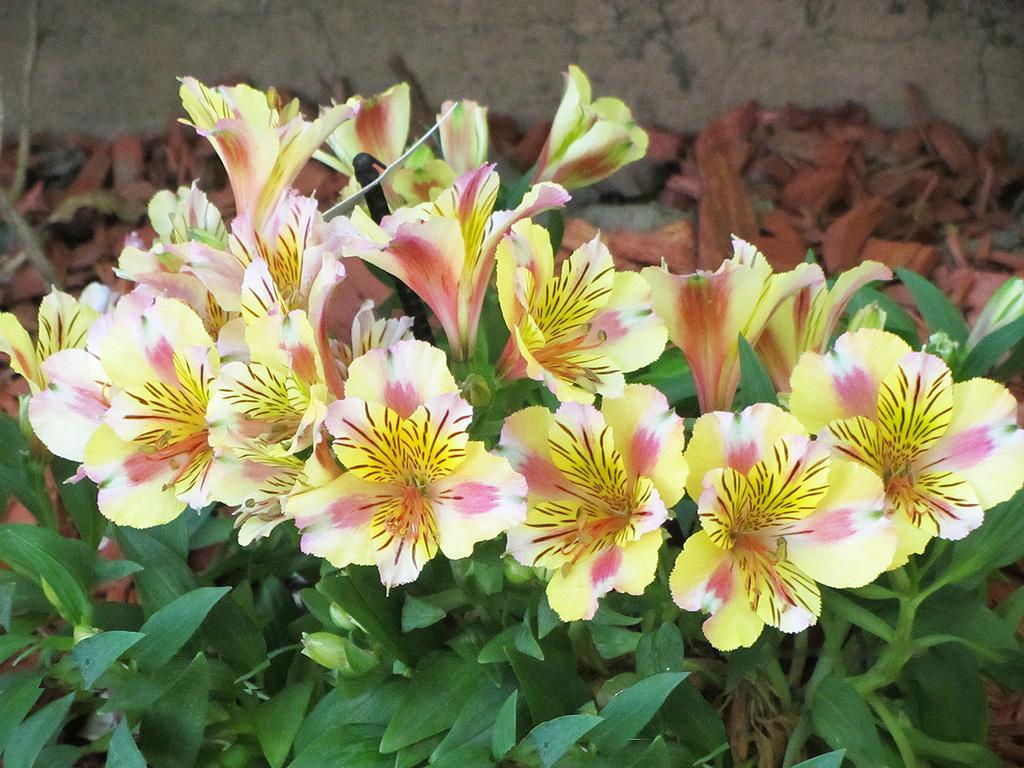Describe this image in one or two sentences. Here we can see plants and flowers. There are dried leaves. 